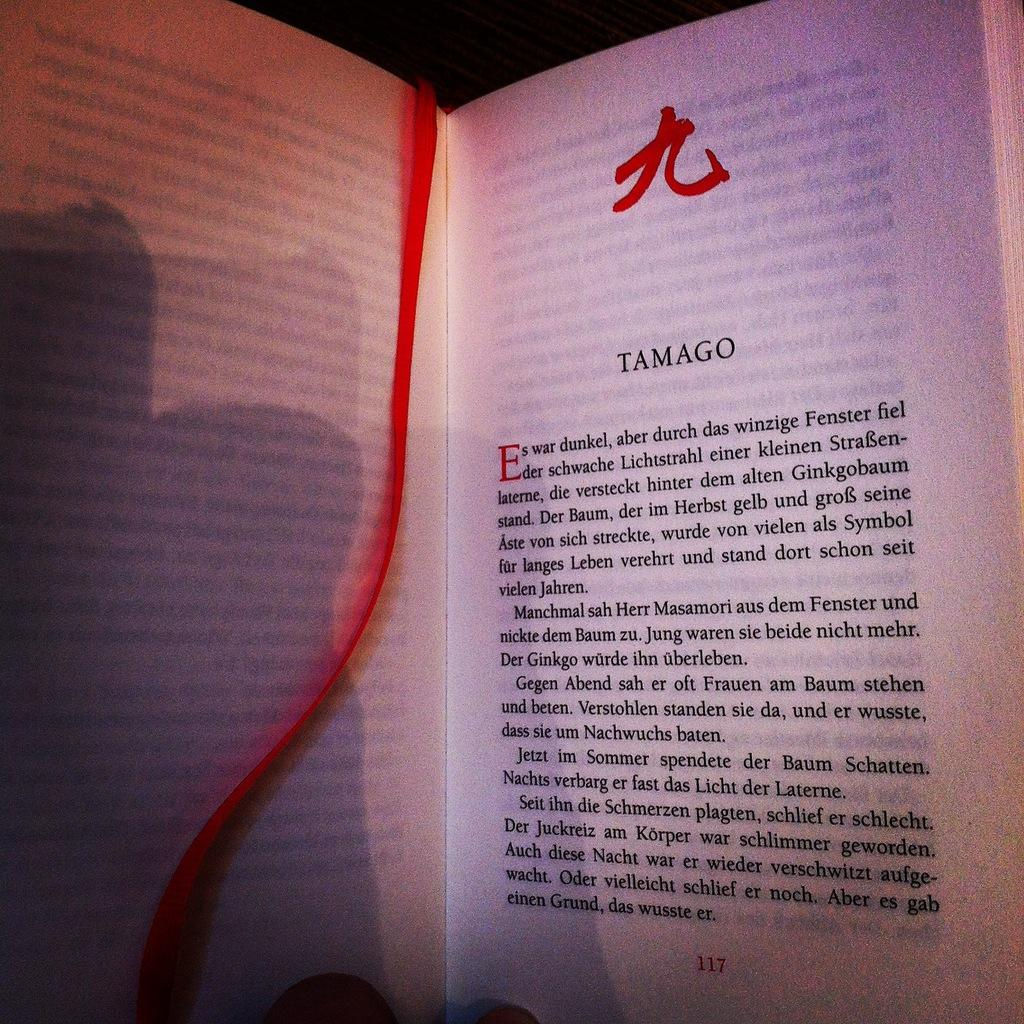<image>
Provide a brief description of the given image. A book is opened to page 117 and a chapter titled TAMAGO. 